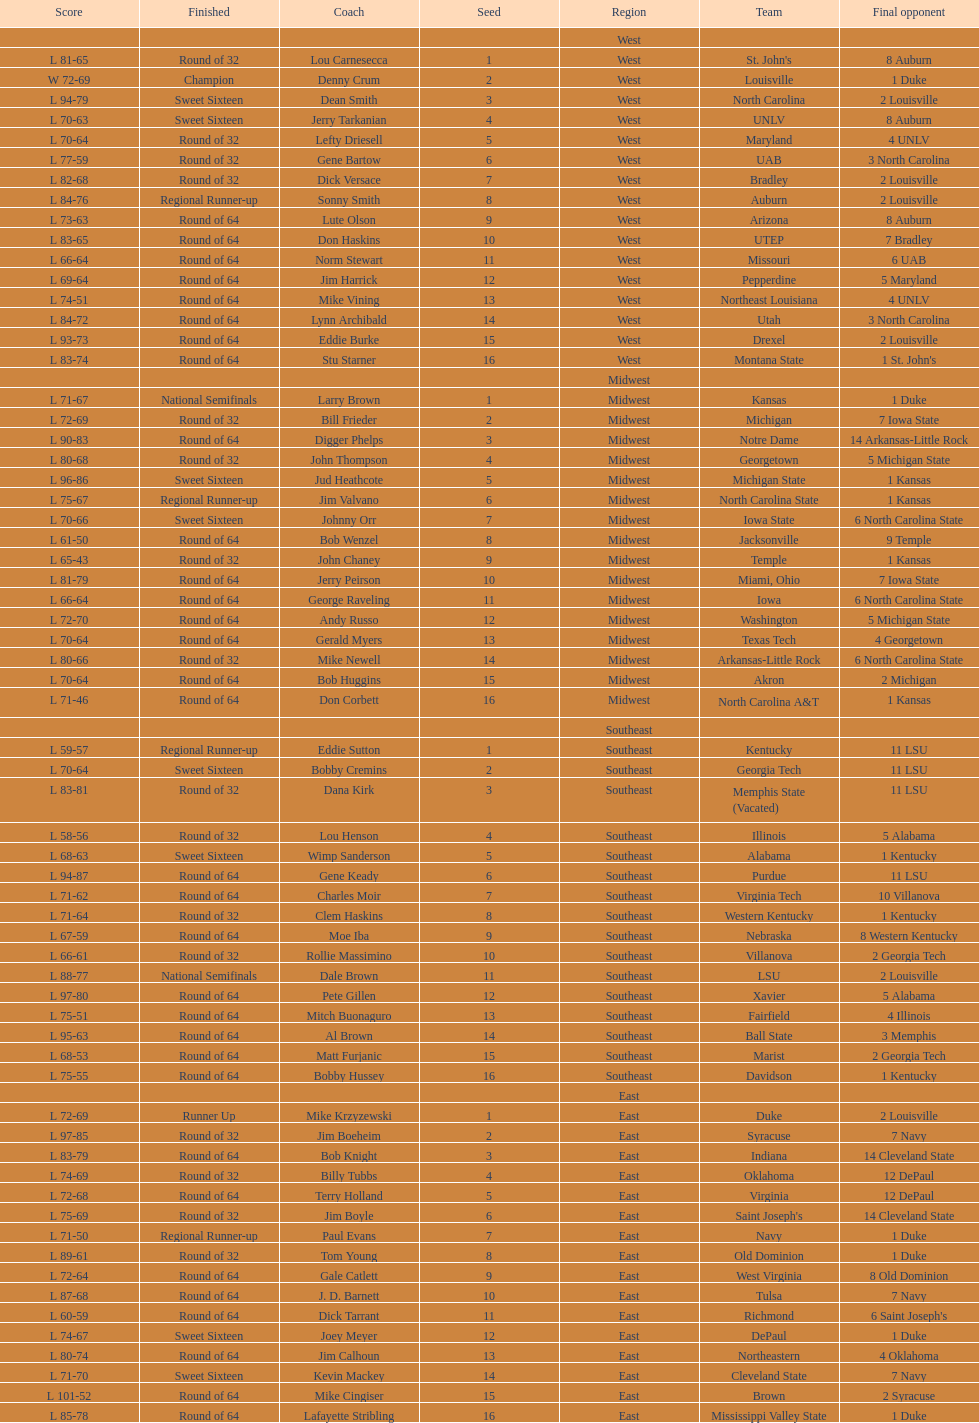How many number of teams played altogether? 64. 